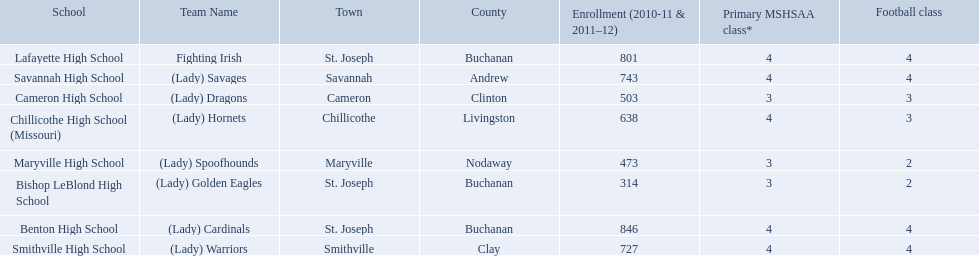How many are enrolled at each school? Benton High School, 846, Bishop LeBlond High School, 314, Cameron High School, 503, Chillicothe High School (Missouri), 638, Lafayette High School, 801, Maryville High School, 473, Savannah High School, 743, Smithville High School, 727. Which school has at only three football classes? Cameron High School, 3, Chillicothe High School (Missouri), 3. Which school has 638 enrolled and 3 football classes? Chillicothe High School (Missouri). 